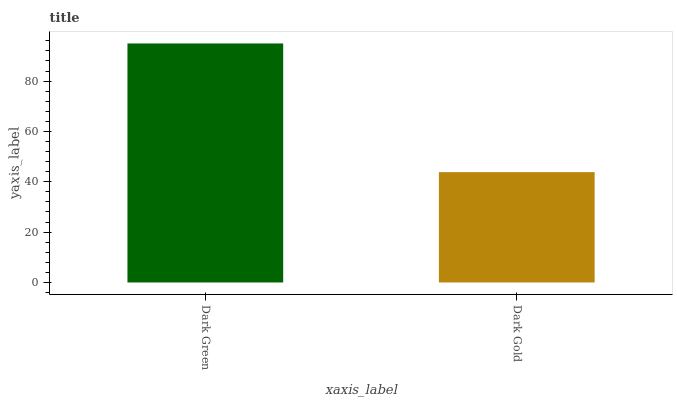Is Dark Gold the maximum?
Answer yes or no. No. Is Dark Green greater than Dark Gold?
Answer yes or no. Yes. Is Dark Gold less than Dark Green?
Answer yes or no. Yes. Is Dark Gold greater than Dark Green?
Answer yes or no. No. Is Dark Green less than Dark Gold?
Answer yes or no. No. Is Dark Green the high median?
Answer yes or no. Yes. Is Dark Gold the low median?
Answer yes or no. Yes. Is Dark Gold the high median?
Answer yes or no. No. Is Dark Green the low median?
Answer yes or no. No. 